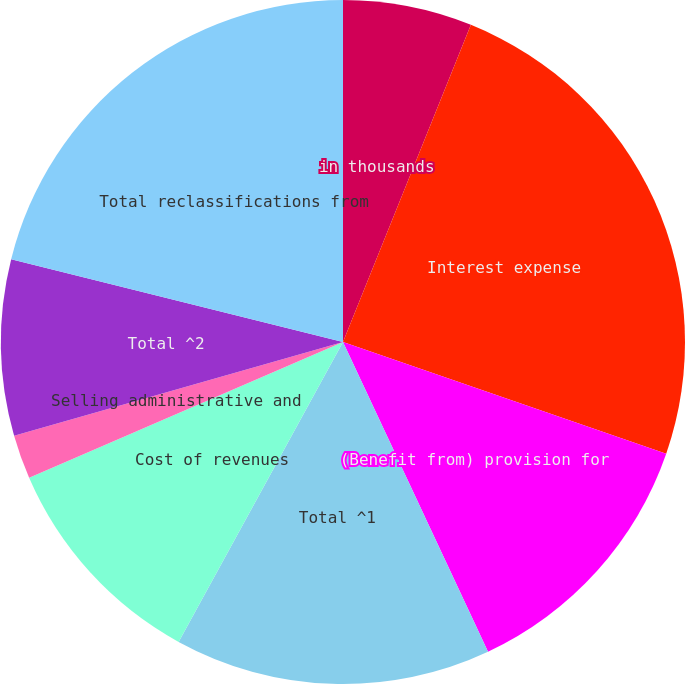Convert chart. <chart><loc_0><loc_0><loc_500><loc_500><pie_chart><fcel>in thousands<fcel>Interest expense<fcel>(Benefit from) provision for<fcel>Total ^1<fcel>Cost of revenues<fcel>Selling administrative and<fcel>Total ^2<fcel>Total reclassifications from<nl><fcel>6.1%<fcel>24.2%<fcel>12.73%<fcel>14.95%<fcel>10.52%<fcel>2.08%<fcel>8.31%<fcel>21.11%<nl></chart> 